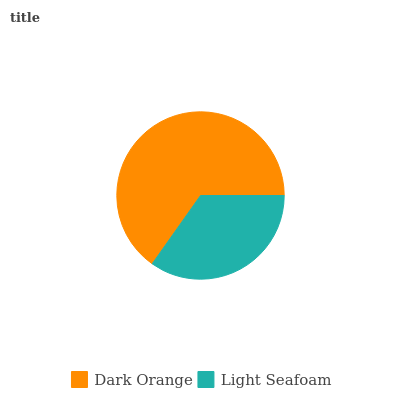Is Light Seafoam the minimum?
Answer yes or no. Yes. Is Dark Orange the maximum?
Answer yes or no. Yes. Is Light Seafoam the maximum?
Answer yes or no. No. Is Dark Orange greater than Light Seafoam?
Answer yes or no. Yes. Is Light Seafoam less than Dark Orange?
Answer yes or no. Yes. Is Light Seafoam greater than Dark Orange?
Answer yes or no. No. Is Dark Orange less than Light Seafoam?
Answer yes or no. No. Is Dark Orange the high median?
Answer yes or no. Yes. Is Light Seafoam the low median?
Answer yes or no. Yes. Is Light Seafoam the high median?
Answer yes or no. No. Is Dark Orange the low median?
Answer yes or no. No. 